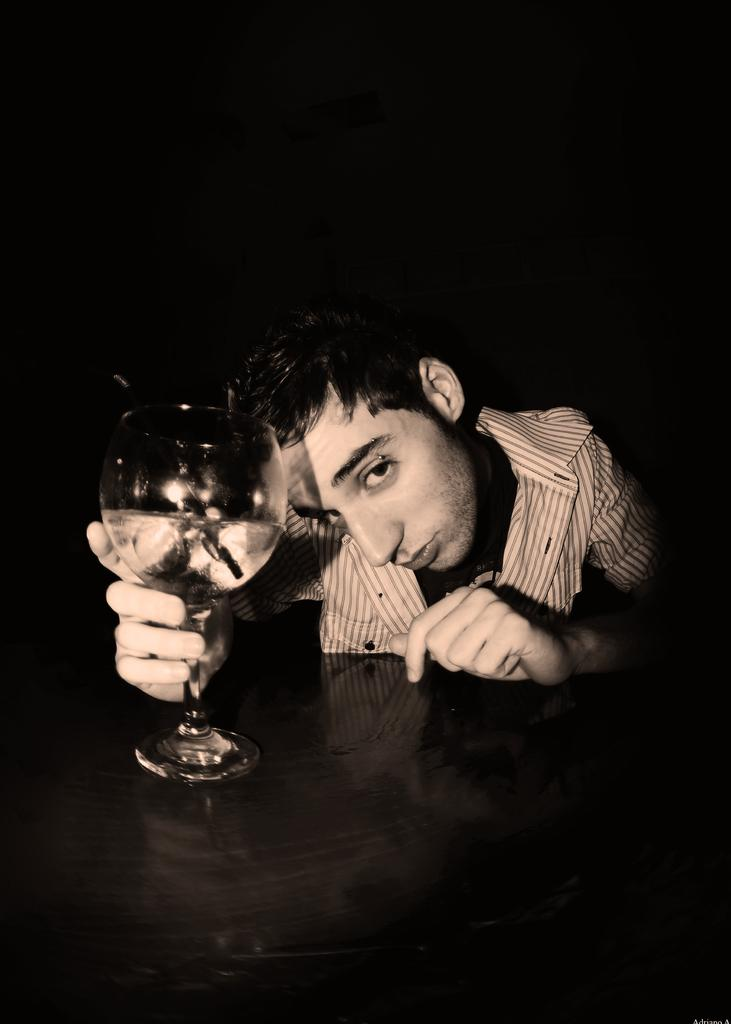Who is present in the image? There is a man in the image. What is the man holding in the image? The man is holding a glass. What type of tent can be seen in the background of the image? There is no tent present in the image. What design is featured on the glass that the man is holding? The provided facts do not mention any design on the glass, so we cannot answer this question. 